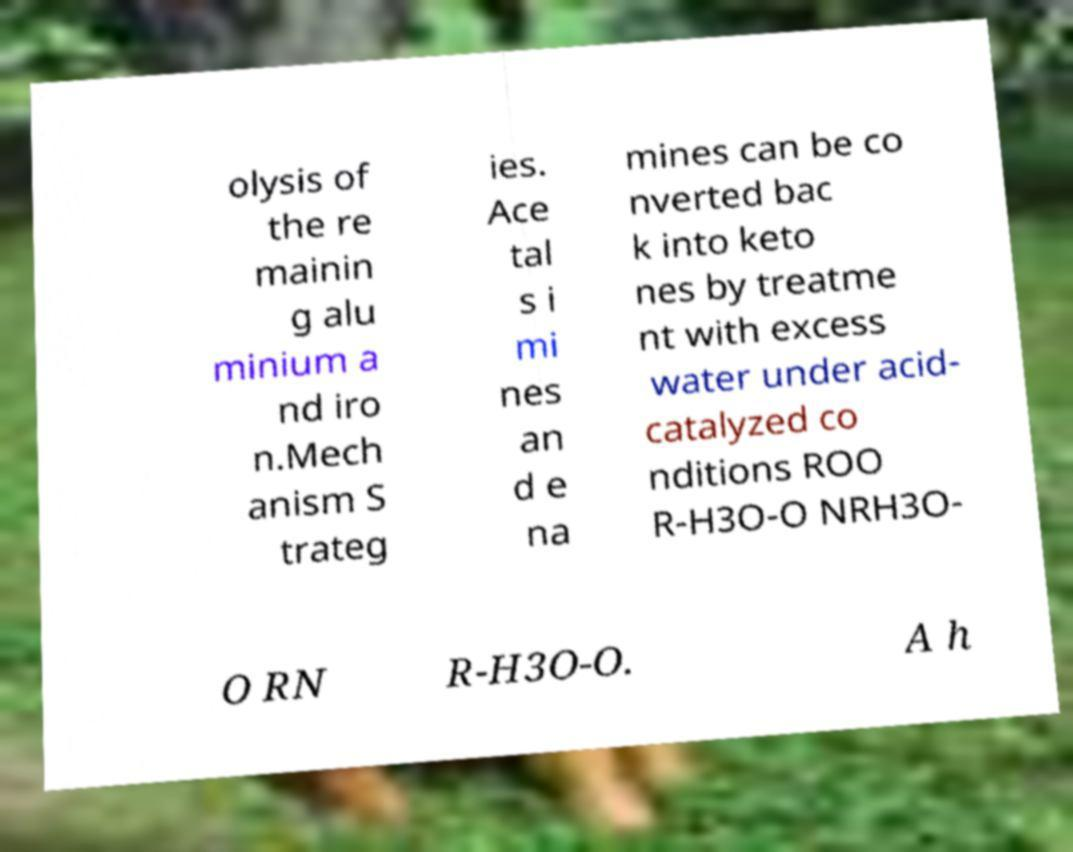Could you assist in decoding the text presented in this image and type it out clearly? olysis of the re mainin g alu minium a nd iro n.Mech anism S trateg ies. Ace tal s i mi nes an d e na mines can be co nverted bac k into keto nes by treatme nt with excess water under acid- catalyzed co nditions ROO R-H3O-O NRH3O- O RN R-H3O-O. A h 